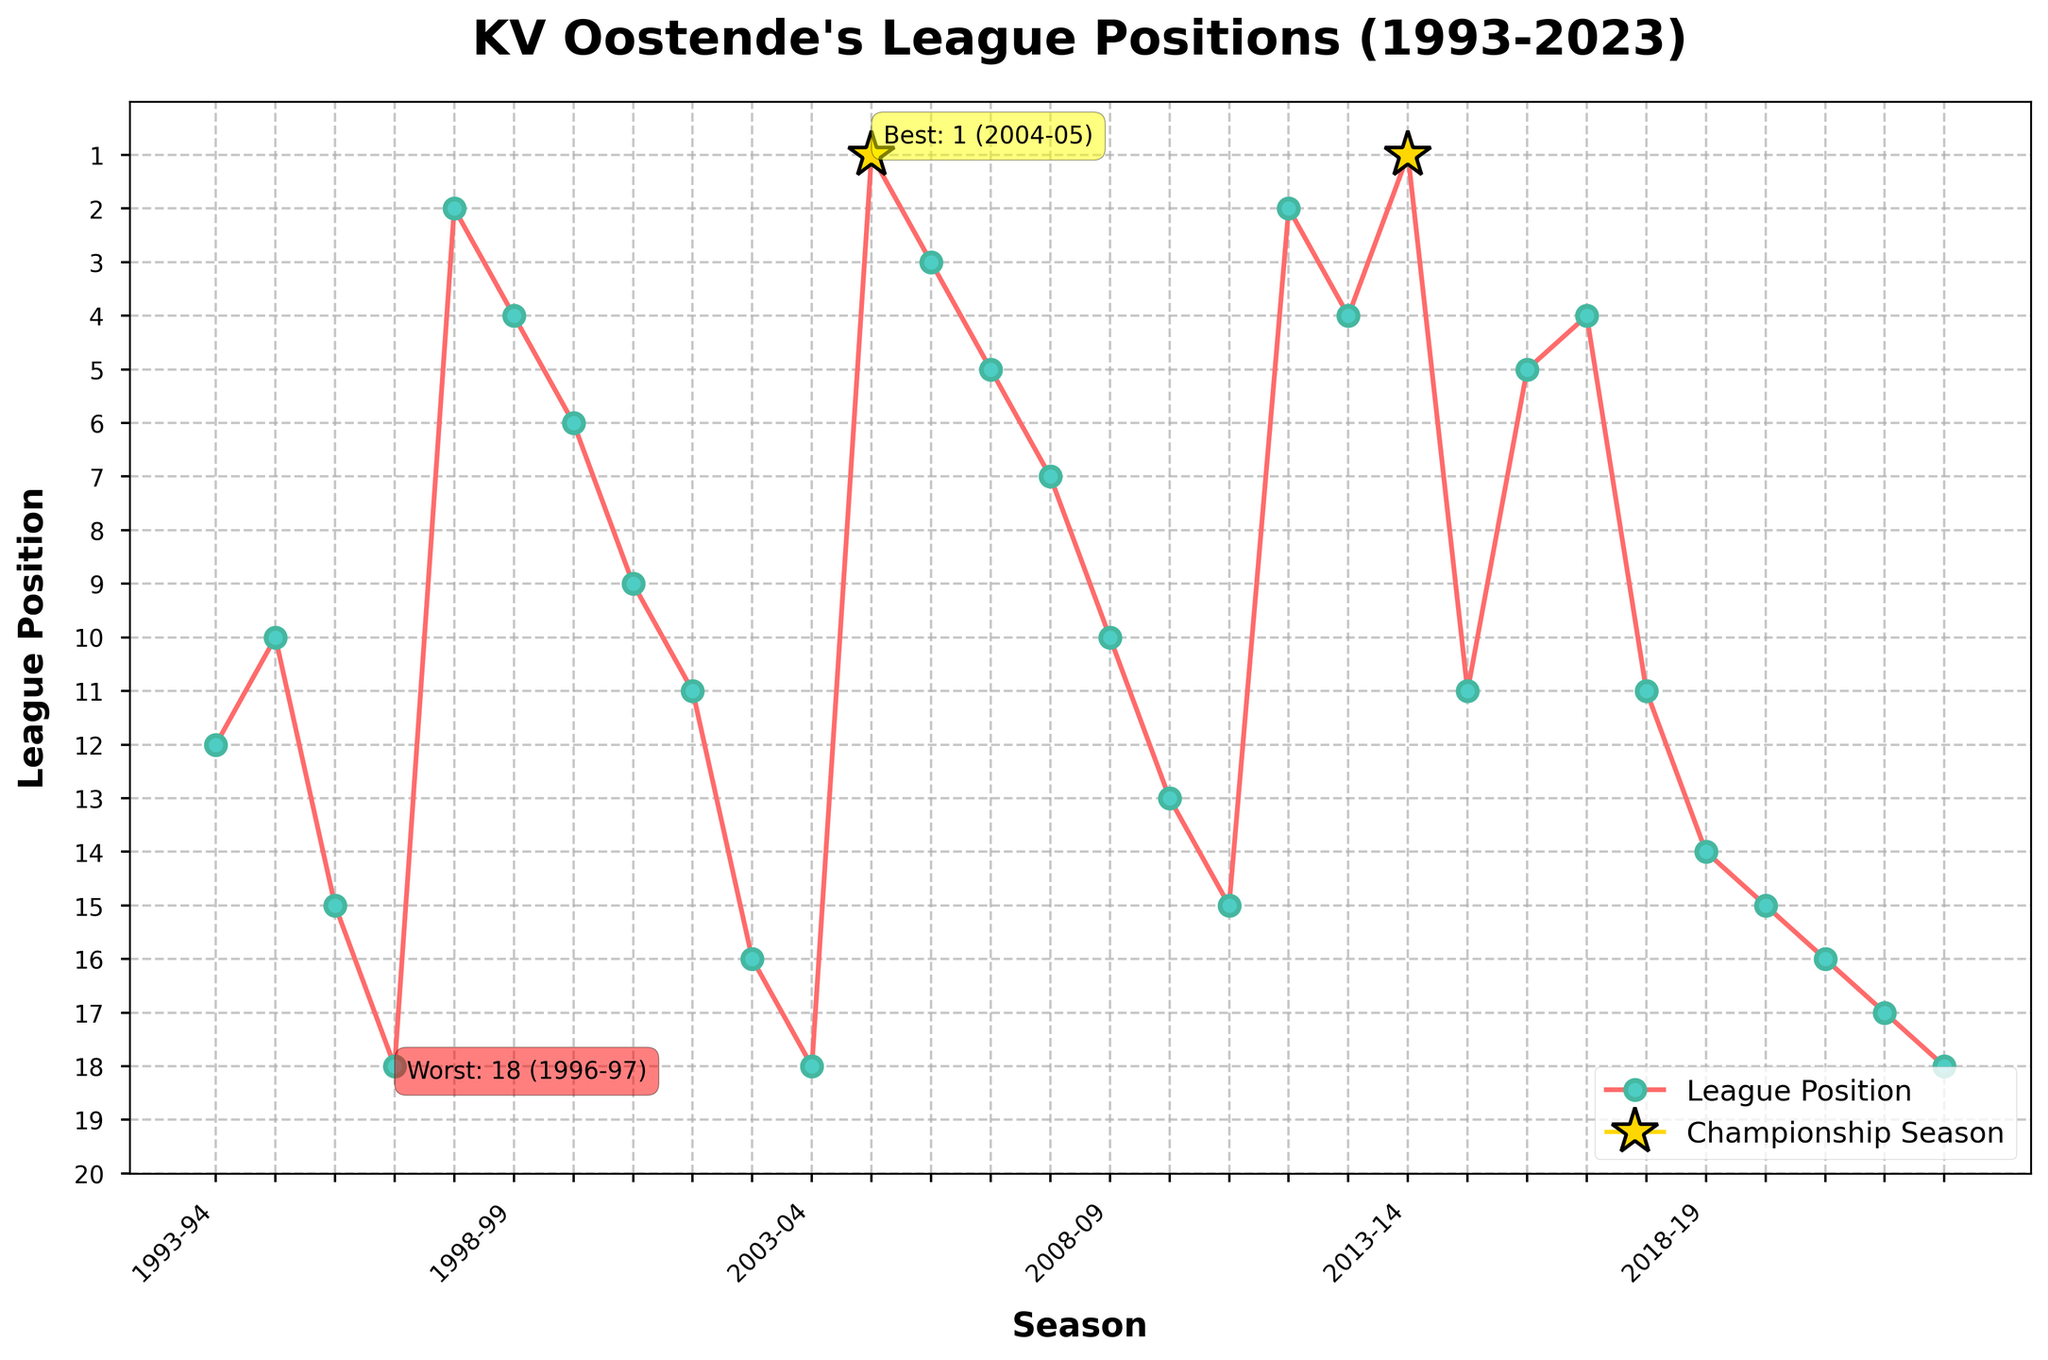What's KV Oostende's best league position in the past 30 seasons? KV Oostende's best league position is marked with a gold star on the plot, with an annotation indicating both the season and the position. The annotation reads 'Best: 1 (2013-14)', referring to their first-place position in the 2013-2014 season.
Answer: 1 How many times did KV Oostende finish at the top position? Based on the gold stars and plot annotations, KV Oostende finished in the top position twice, once in the 2004-05 season and again in the 2013-14 season.
Answer: 2 Which season did KV Oostende experience their worst league position, and what was it? The worst league position is annotated on the plot, reading 'Worst: 18 (2022-23)', indicating it was the 2022-2023 season.
Answer: 2022-23, 18 What is the trend in league positions for KV Oostende from the 2003-04 season to the 2004-05 season? Observing the line chart from the 2003-04 to 2004-05 seasons, there is a significant upward trend where their position improved from 18th place in 2003-04 to 1st place in 2004-05.
Answer: Upward trend Between which consecutive seasons did KV Oostende see the most substantial drop in league position? The biggest drop is seen between the 2013-14 and 2014-15 seasons, where their position fell from 1st place to 11th place. The difference is 10 positions (1 - 11 = -10).
Answer: 2013-14 to 2014-15 Which season had a higher league position, 2016-17 or 2019-20? By looking at the positions in the respective seasons on the line chart, 2016-17 has a higher league position (4th) compared to 2019-20 (15th).
Answer: 2016-17 How did KV Oostende's league position change from the 2007-08 season to the 2008-09 season? The league position deteriorated; it moved from 7th in 2007-08 to 10th in 2008-09.
Answer: Worsened In which seasons did KV Oostende finish in the 2nd position? The line chart shows that KV Oostende finished 2nd twice, once in the 1997-98 season and again in the 2011-12 season.
Answer: 1997-98, 2011-12 What's the average league position of KV Oostende over these 30 seasons? To calculate the average, sum up all the league positions (12 + 10 + 15 + 18 + 2 + 4 + 6 + 9 + 11 + 16 + 18 + 1 + 3 + 5 + 7 + 10 + 13 + 15 + 2 + 4 + 1 + 11 + 5 + 4 + 11 + 14 + 15 + 16 + 17 + 18 = 303) and divide by the number of seasons (30). The average league position is 303 / 30 = 10.1.
Answer: 10.1 